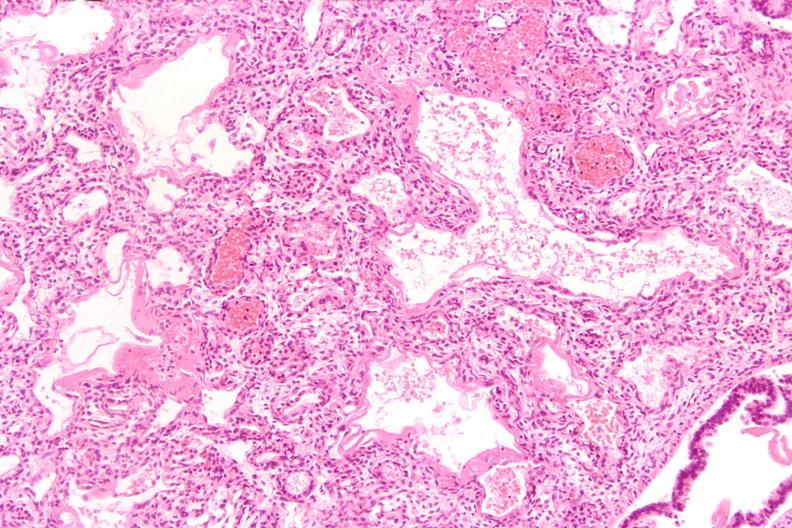where is this?
Answer the question using a single word or phrase. Lung 